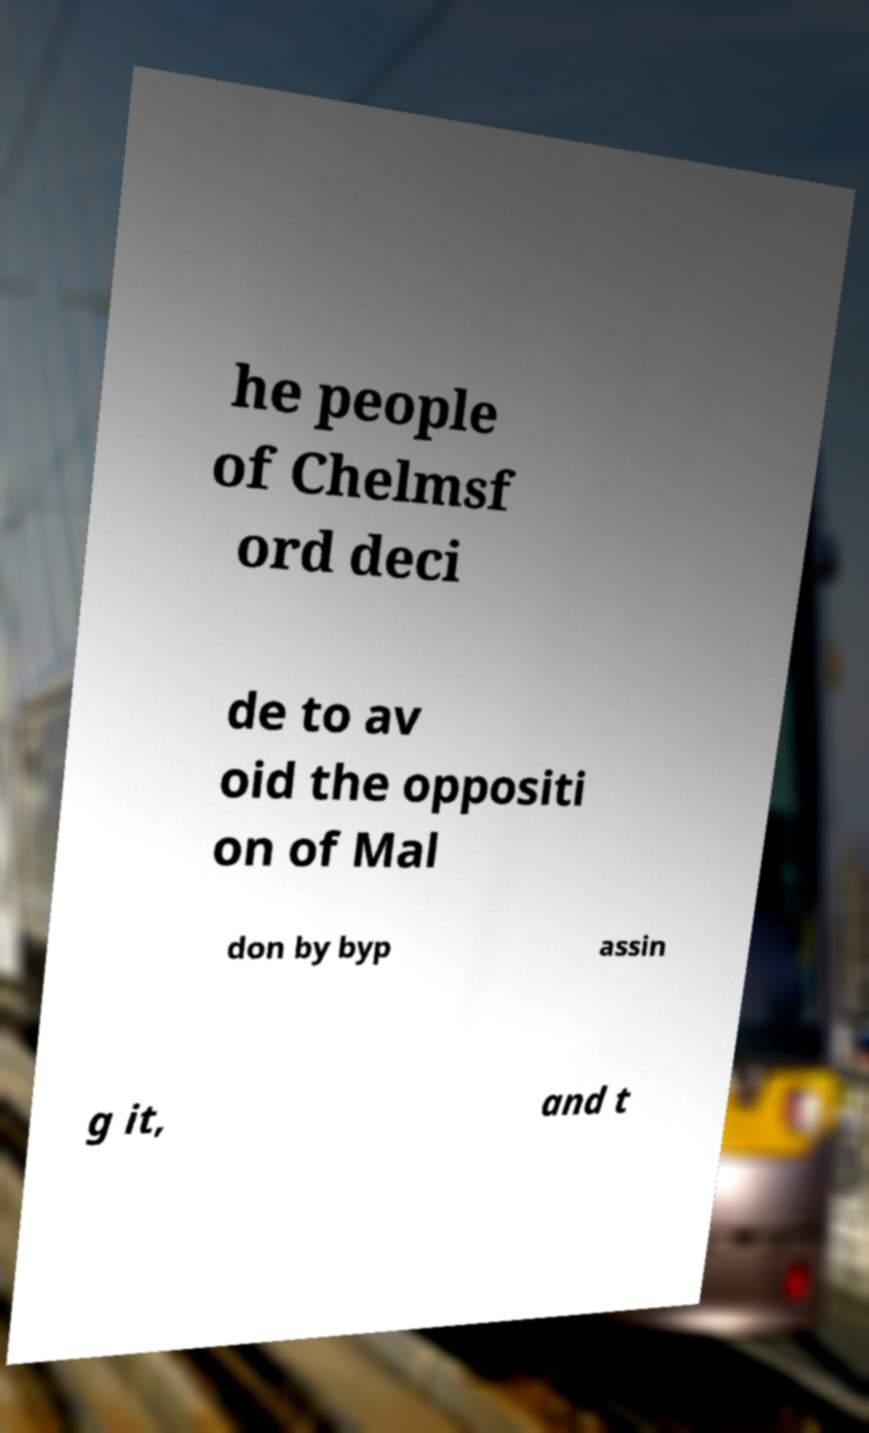I need the written content from this picture converted into text. Can you do that? he people of Chelmsf ord deci de to av oid the oppositi on of Mal don by byp assin g it, and t 